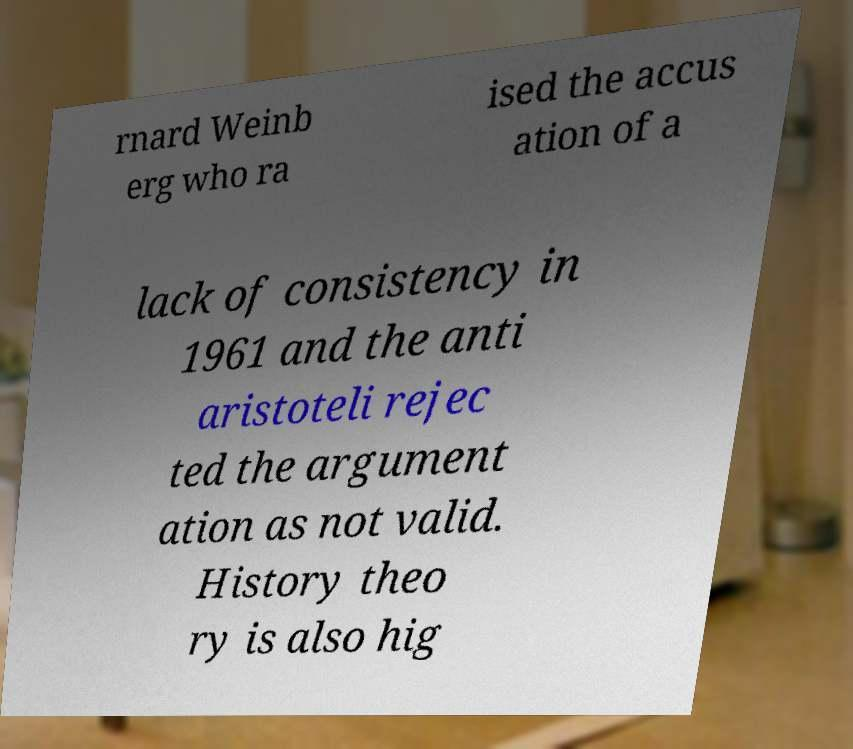Can you read and provide the text displayed in the image?This photo seems to have some interesting text. Can you extract and type it out for me? rnard Weinb erg who ra ised the accus ation of a lack of consistency in 1961 and the anti aristoteli rejec ted the argument ation as not valid. History theo ry is also hig 